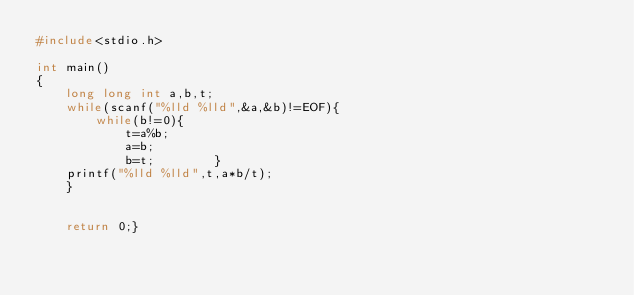Convert code to text. <code><loc_0><loc_0><loc_500><loc_500><_C_>#include<stdio.h>

int main()
{
	long long int a,b,t;
	while(scanf("%lld %lld",&a,&b)!=EOF){
		while(b!=0){
			t=a%b;
			a=b;
			b=t;		}
	printf("%lld %lld",t,a*b/t);		
	}


    return 0;}</code> 